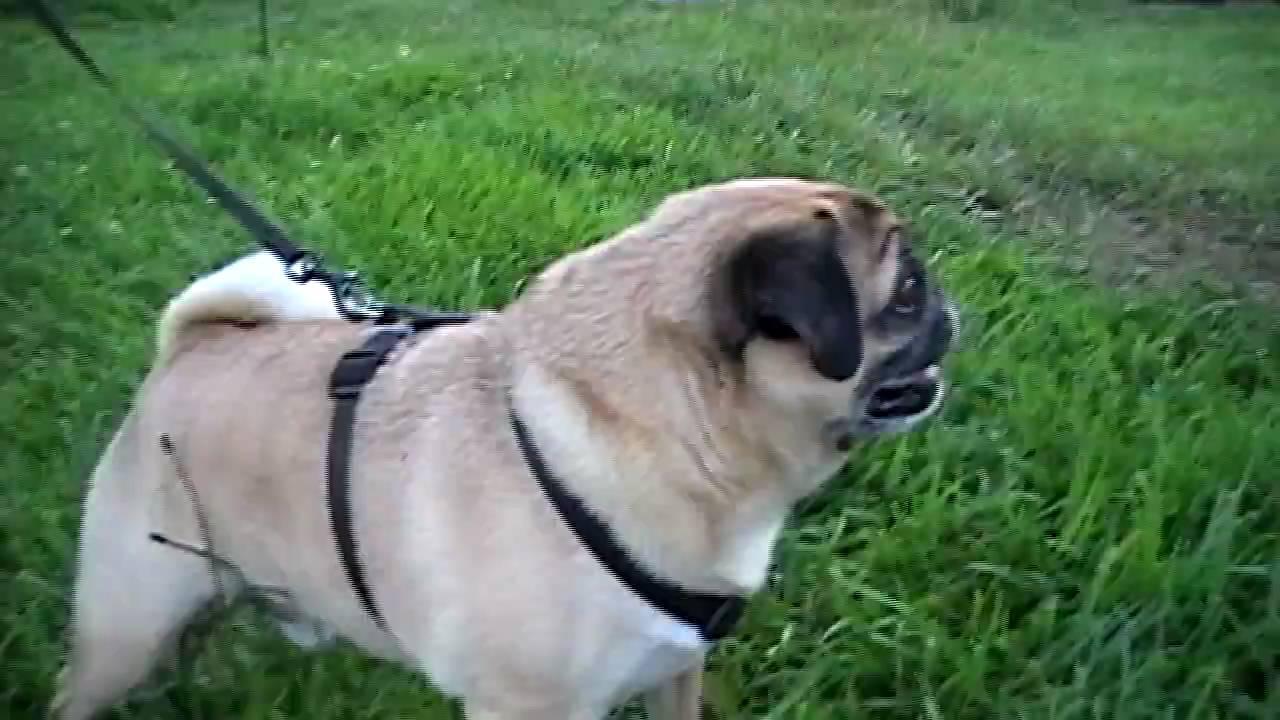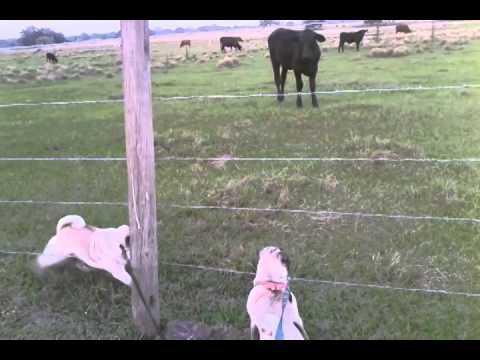The first image is the image on the left, the second image is the image on the right. Examine the images to the left and right. Is the description "The dogs on the left are dressed like cows." accurate? Answer yes or no. No. The first image is the image on the left, the second image is the image on the right. Considering the images on both sides, is "The left image includes a dog wearing a black and white cow print costume." valid? Answer yes or no. No. 